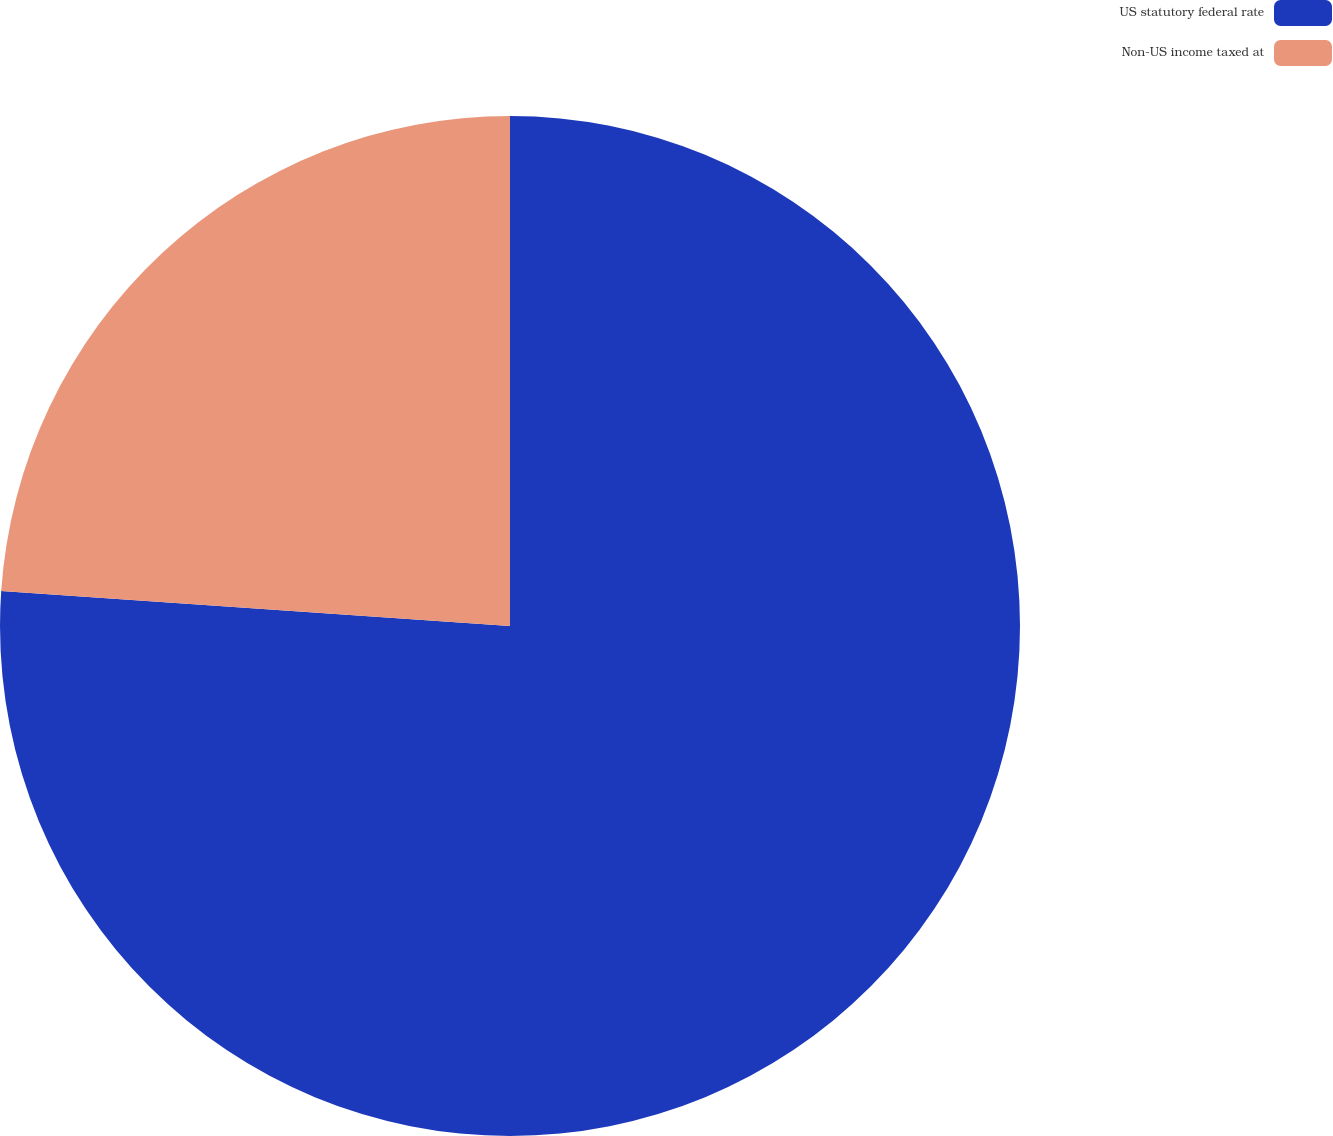<chart> <loc_0><loc_0><loc_500><loc_500><pie_chart><fcel>US statutory federal rate<fcel>Non-US income taxed at<nl><fcel>76.09%<fcel>23.91%<nl></chart> 